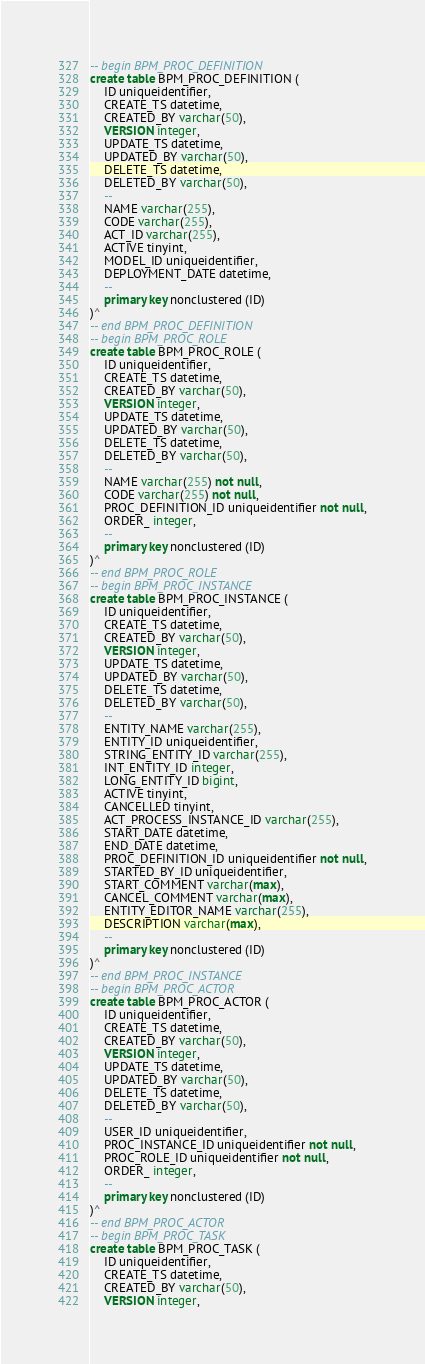<code> <loc_0><loc_0><loc_500><loc_500><_SQL_>-- begin BPM_PROC_DEFINITION
create table BPM_PROC_DEFINITION (
    ID uniqueidentifier,
    CREATE_TS datetime,
    CREATED_BY varchar(50),
    VERSION integer,
    UPDATE_TS datetime,
    UPDATED_BY varchar(50),
    DELETE_TS datetime,
    DELETED_BY varchar(50),
    --
    NAME varchar(255),
    CODE varchar(255),
    ACT_ID varchar(255),
    ACTIVE tinyint,
    MODEL_ID uniqueidentifier,
    DEPLOYMENT_DATE datetime,
    --
    primary key nonclustered (ID)
)^
-- end BPM_PROC_DEFINITION
-- begin BPM_PROC_ROLE
create table BPM_PROC_ROLE (
    ID uniqueidentifier,
    CREATE_TS datetime,
    CREATED_BY varchar(50),
    VERSION integer,
    UPDATE_TS datetime,
    UPDATED_BY varchar(50),
    DELETE_TS datetime,
    DELETED_BY varchar(50),
    --
    NAME varchar(255) not null,
    CODE varchar(255) not null,
    PROC_DEFINITION_ID uniqueidentifier not null,
    ORDER_ integer,
    --
    primary key nonclustered (ID)
)^
-- end BPM_PROC_ROLE
-- begin BPM_PROC_INSTANCE
create table BPM_PROC_INSTANCE (
    ID uniqueidentifier,
    CREATE_TS datetime,
    CREATED_BY varchar(50),
    VERSION integer,
    UPDATE_TS datetime,
    UPDATED_BY varchar(50),
    DELETE_TS datetime,
    DELETED_BY varchar(50),
    --
    ENTITY_NAME varchar(255),
    ENTITY_ID uniqueidentifier,
    STRING_ENTITY_ID varchar(255),
    INT_ENTITY_ID integer,
    LONG_ENTITY_ID bigint,
    ACTIVE tinyint,
    CANCELLED tinyint,
    ACT_PROCESS_INSTANCE_ID varchar(255),
    START_DATE datetime,
    END_DATE datetime,
    PROC_DEFINITION_ID uniqueidentifier not null,
    STARTED_BY_ID uniqueidentifier,
    START_COMMENT varchar(max),
    CANCEL_COMMENT varchar(max),
    ENTITY_EDITOR_NAME varchar(255),
    DESCRIPTION varchar(max),
    --
    primary key nonclustered (ID)
)^
-- end BPM_PROC_INSTANCE
-- begin BPM_PROC_ACTOR
create table BPM_PROC_ACTOR (
    ID uniqueidentifier,
    CREATE_TS datetime,
    CREATED_BY varchar(50),
    VERSION integer,
    UPDATE_TS datetime,
    UPDATED_BY varchar(50),
    DELETE_TS datetime,
    DELETED_BY varchar(50),
    --
    USER_ID uniqueidentifier,
    PROC_INSTANCE_ID uniqueidentifier not null,
    PROC_ROLE_ID uniqueidentifier not null,
    ORDER_ integer,
    --
    primary key nonclustered (ID)
)^
-- end BPM_PROC_ACTOR
-- begin BPM_PROC_TASK
create table BPM_PROC_TASK (
    ID uniqueidentifier,
    CREATE_TS datetime,
    CREATED_BY varchar(50),
    VERSION integer,</code> 